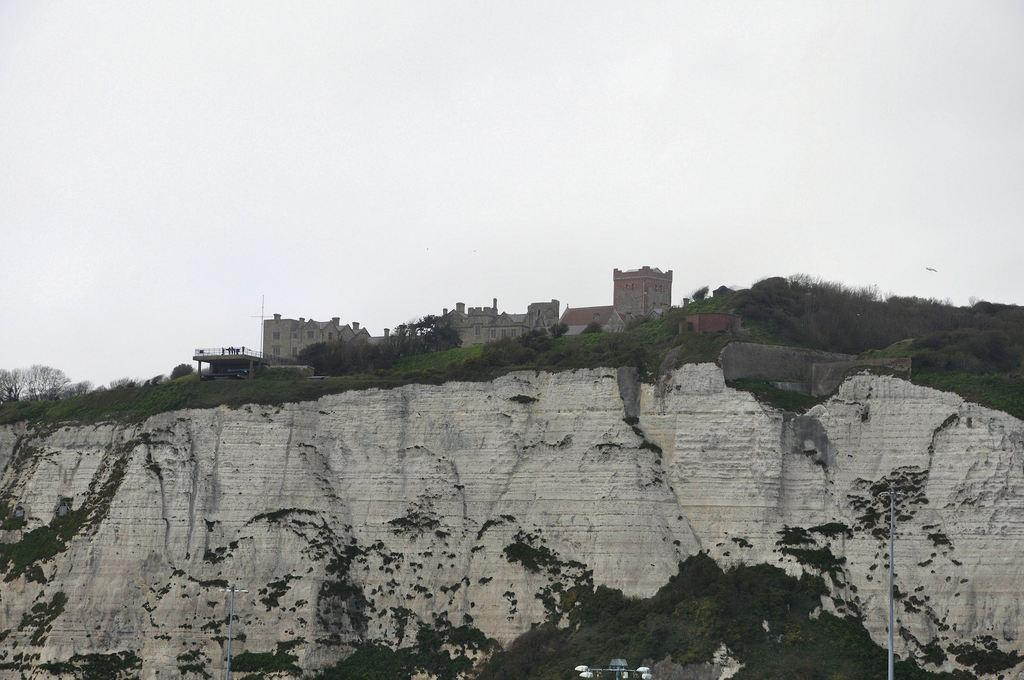What geographical feature is present in the image? There is a hill in the image. What can be found on the top of the hill? There are plants and buildings on the top of the hill. What objects are located at the bottom of the image? There are two poles at the bottom of the image. What is visible at the top of the image? The sky is visible at the top of the image. Where is the faucet located in the image? There is no faucet present in the image. What type of structure is being discovered at the top of the hill in the image? There is no mention of a discovery or a specific structure in the image. 